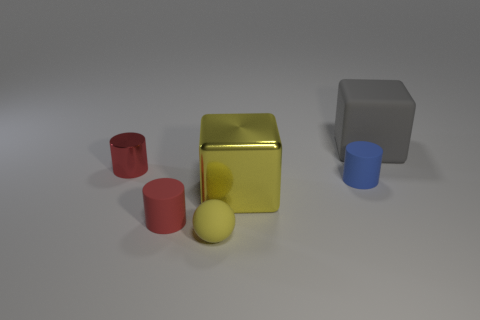There is a small red thing right of the cylinder that is behind the small blue thing; what is its material?
Keep it short and to the point. Rubber. Do the yellow cube and the rubber block have the same size?
Your answer should be very brief. Yes. How many objects are small red objects that are to the left of the tiny red rubber thing or yellow cubes?
Your answer should be compact. 2. What is the shape of the tiny red thing behind the tiny red cylinder that is on the right side of the tiny red metal cylinder?
Keep it short and to the point. Cylinder. Is the size of the gray cube the same as the metal object that is behind the tiny blue object?
Your answer should be very brief. No. There is a big gray thing that is behind the yellow ball; what is it made of?
Your answer should be compact. Rubber. How many things are both to the right of the shiny cylinder and in front of the big rubber thing?
Give a very brief answer. 4. What is the material of the yellow thing that is the same size as the gray cube?
Give a very brief answer. Metal. There is a yellow thing left of the yellow shiny block; does it have the same size as the blue rubber thing on the left side of the gray thing?
Give a very brief answer. Yes. Are there any red shiny things in front of the blue rubber thing?
Give a very brief answer. No. 